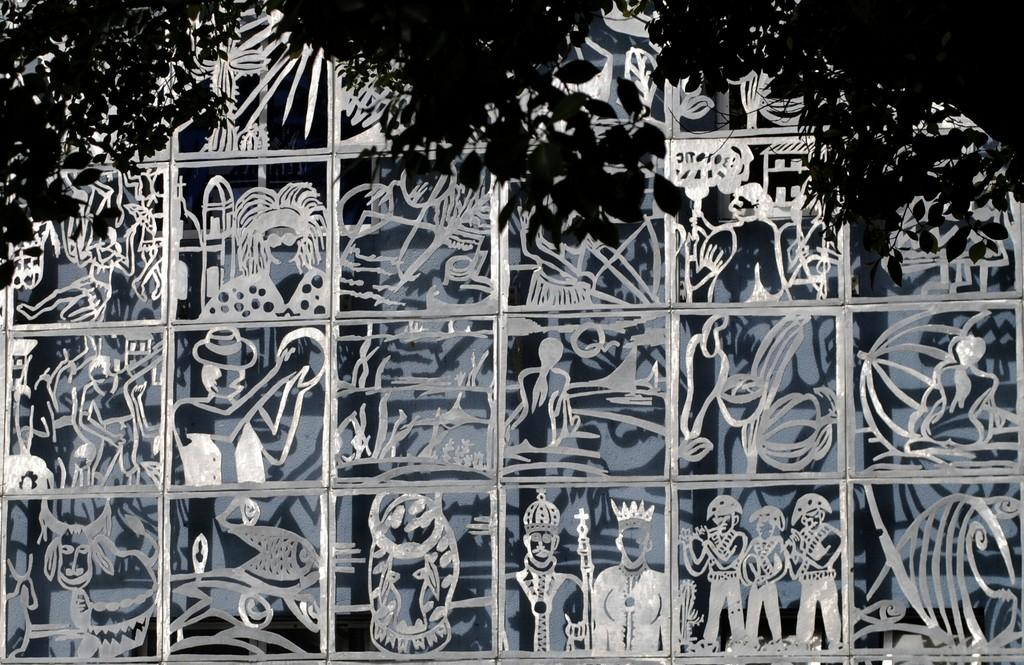What is the color scheme of the image? The image is black and white. What can be seen on the glass in the image? There is art on the glass in the image. What type of natural scenery is visible at the top of the image? There are trees visible at the top of the image. Where is the quilt located in the image? There is no quilt present in the image. How many clovers can be seen growing in the wilderness in the image? There is no wilderness or clovers present in the image; it is a black and white image with art on the glass and trees visible at the top. 